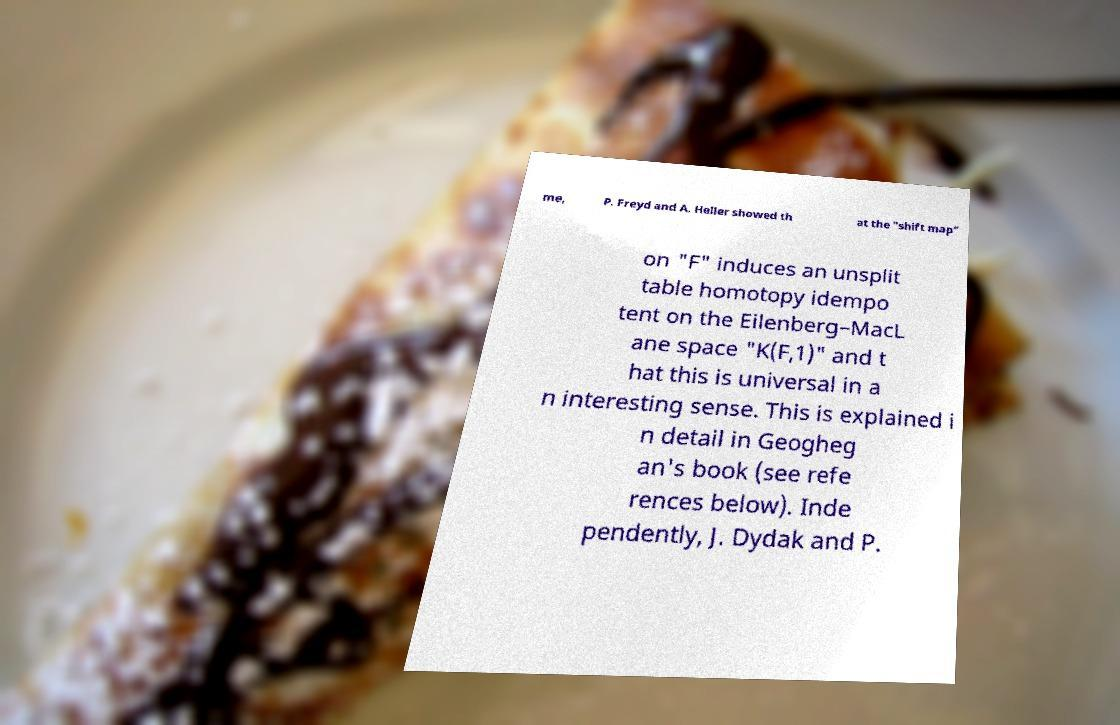Can you accurately transcribe the text from the provided image for me? me, P. Freyd and A. Heller showed th at the "shift map" on "F" induces an unsplit table homotopy idempo tent on the Eilenberg–MacL ane space "K(F,1)" and t hat this is universal in a n interesting sense. This is explained i n detail in Geogheg an's book (see refe rences below). Inde pendently, J. Dydak and P. 